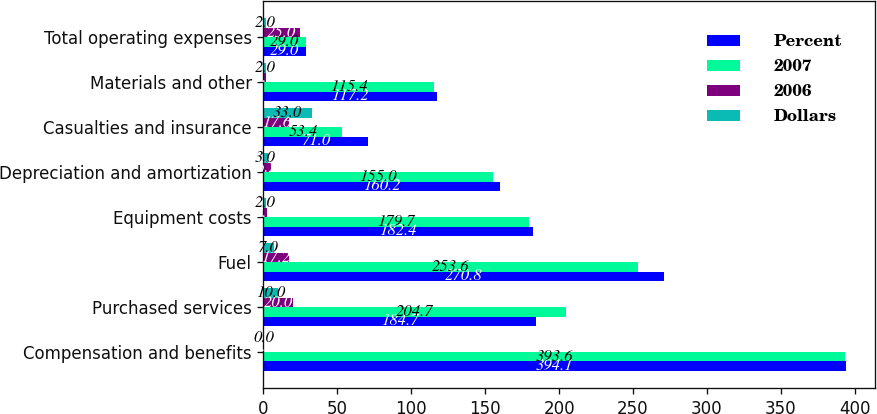<chart> <loc_0><loc_0><loc_500><loc_500><stacked_bar_chart><ecel><fcel>Compensation and benefits<fcel>Purchased services<fcel>Fuel<fcel>Equipment costs<fcel>Depreciation and amortization<fcel>Casualties and insurance<fcel>Materials and other<fcel>Total operating expenses<nl><fcel>Percent<fcel>394.1<fcel>184.7<fcel>270.8<fcel>182.4<fcel>160.2<fcel>71<fcel>117.2<fcel>29<nl><fcel>2007<fcel>393.6<fcel>204.7<fcel>253.6<fcel>179.7<fcel>155<fcel>53.4<fcel>115.4<fcel>29<nl><fcel>2006<fcel>0.5<fcel>20<fcel>17.2<fcel>2.7<fcel>5.2<fcel>17.6<fcel>1.8<fcel>25<nl><fcel>Dollars<fcel>0<fcel>10<fcel>7<fcel>2<fcel>3<fcel>33<fcel>2<fcel>2<nl></chart> 